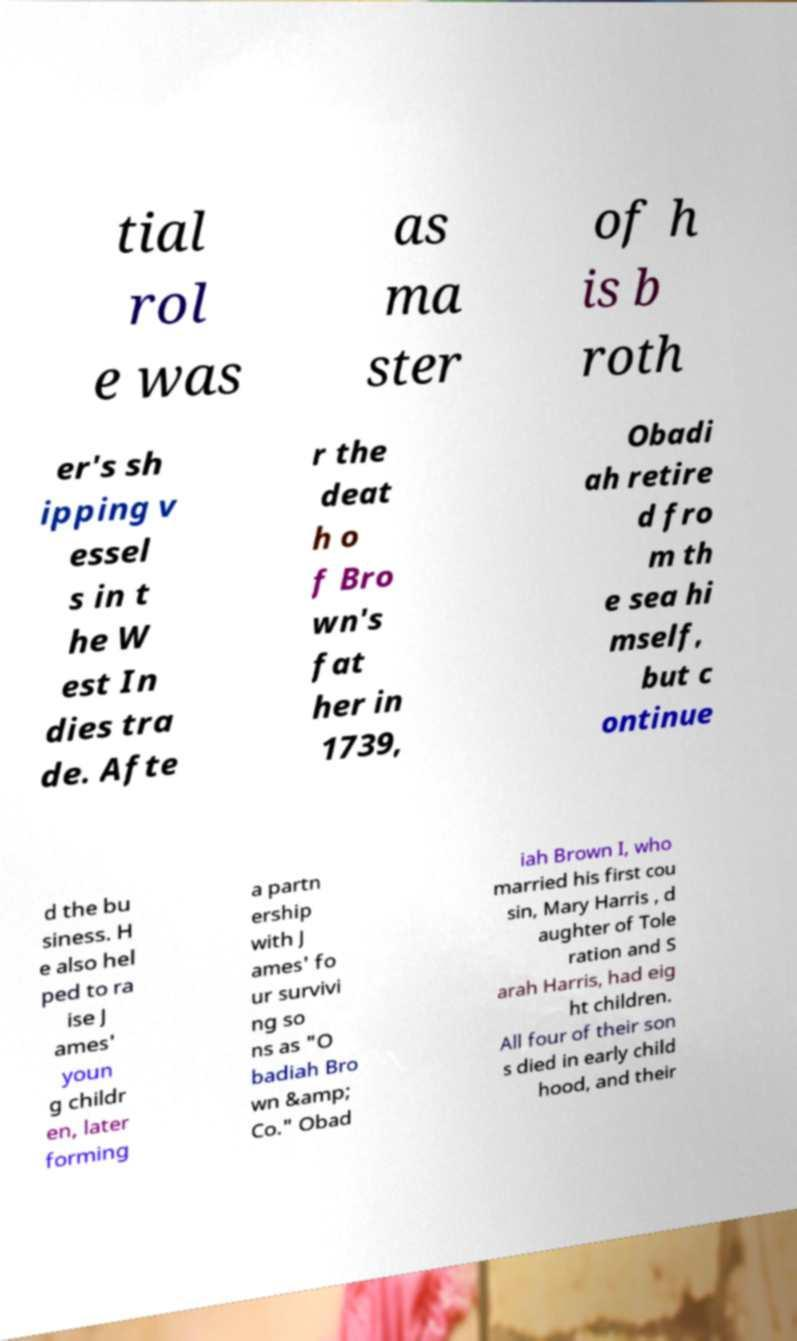Could you assist in decoding the text presented in this image and type it out clearly? tial rol e was as ma ster of h is b roth er's sh ipping v essel s in t he W est In dies tra de. Afte r the deat h o f Bro wn's fat her in 1739, Obadi ah retire d fro m th e sea hi mself, but c ontinue d the bu siness. H e also hel ped to ra ise J ames' youn g childr en, later forming a partn ership with J ames' fo ur survivi ng so ns as "O badiah Bro wn &amp; Co." Obad iah Brown I, who married his first cou sin, Mary Harris , d aughter of Tole ration and S arah Harris, had eig ht children. All four of their son s died in early child hood, and their 